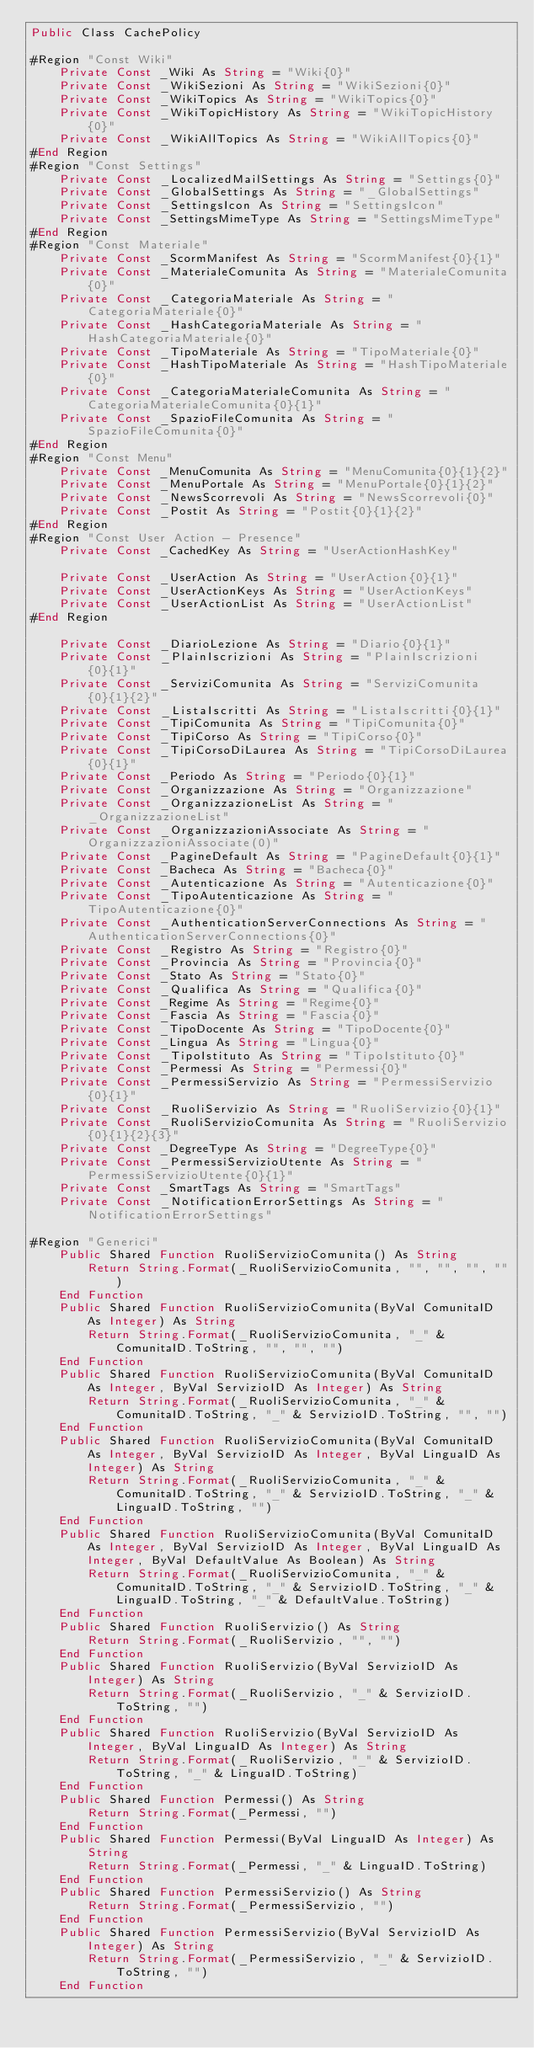<code> <loc_0><loc_0><loc_500><loc_500><_VisualBasic_>Public Class CachePolicy

#Region "Const Wiki"
	Private Const _Wiki As String = "Wiki{0}"
	Private Const _WikiSezioni As String = "WikiSezioni{0}"
	Private Const _WikiTopics As String = "WikiTopics{0}"
	Private Const _WikiTopicHistory As String = "WikiTopicHistory{0}"
	Private Const _WikiAllTopics As String = "WikiAllTopics{0}"
#End Region
#Region "Const Settings"
	Private Const _LocalizedMailSettings As String = "Settings{0}"
	Private Const _GlobalSettings As String = "_GlobalSettings"
	Private Const _SettingsIcon As String = "SettingsIcon"
	Private Const _SettingsMimeType As String = "SettingsMimeType"
#End Region
#Region "Const Materiale"
	Private Const _ScormManifest As String = "ScormManifest{0}{1}"
	Private Const _MaterialeComunita As String = "MaterialeComunita{0}"
	Private Const _CategoriaMateriale As String = "CategoriaMateriale{0}"
	Private Const _HashCategoriaMateriale As String = "HashCategoriaMateriale{0}"
	Private Const _TipoMateriale As String = "TipoMateriale{0}"
	Private Const _HashTipoMateriale As String = "HashTipoMateriale{0}"
	Private Const _CategoriaMaterialeComunita As String = "CategoriaMaterialeComunita{0}{1}"
	Private Const _SpazioFileComunita As String = "SpazioFileComunita{0}"
#End Region
#Region "Const Menu"
	Private Const _MenuComunita As String = "MenuComunita{0}{1}{2}"
	Private Const _MenuPortale As String = "MenuPortale{0}{1}{2}"
	Private Const _NewsScorrevoli As String = "NewsScorrevoli{0}"
	Private Const _Postit As String = "Postit{0}{1}{2}"
#End Region
#Region "Const User Action - Presence"
    Private Const _CachedKey As String = "UserActionHashKey"

    Private Const _UserAction As String = "UserAction{0}{1}"
    Private Const _UserActionKeys As String = "UserActionKeys"
    Private Const _UserActionList As String = "UserActionList"
#End Region

    Private Const _DiarioLezione As String = "Diario{0}{1}"
    Private Const _PlainIscrizioni As String = "PlainIscrizioni{0}{1}"
    Private Const _ServiziComunita As String = "ServiziComunita{0}{1}{2}"
    Private Const _ListaIscritti As String = "ListaIscritti{0}{1}"
    Private Const _TipiComunita As String = "TipiComunita{0}"
    Private Const _TipiCorso As String = "TipiCorso{0}"
    Private Const _TipiCorsoDiLaurea As String = "TipiCorsoDiLaurea{0}{1}"
    Private Const _Periodo As String = "Periodo{0}{1}"
    Private Const _Organizzazione As String = "Organizzazione"
    Private Const _OrganizzazioneList As String = "_OrganizzazioneList"
    Private Const _OrganizzazioniAssociate As String = "OrganizzazioniAssociate(0)"
    Private Const _PagineDefault As String = "PagineDefault{0}{1}"
    Private Const _Bacheca As String = "Bacheca{0}"
    Private Const _Autenticazione As String = "Autenticazione{0}"
    Private Const _TipoAutenticazione As String = "TipoAutenticazione{0}"
    Private Const _AuthenticationServerConnections As String = "AuthenticationServerConnections{0}"
    Private Const _Registro As String = "Registro{0}"
    Private Const _Provincia As String = "Provincia{0}"
    Private Const _Stato As String = "Stato{0}"
    Private Const _Qualifica As String = "Qualifica{0}"
    Private Const _Regime As String = "Regime{0}"
    Private Const _Fascia As String = "Fascia{0}"
    Private Const _TipoDocente As String = "TipoDocente{0}"
    Private Const _Lingua As String = "Lingua{0}"
    Private Const _TipoIstituto As String = "TipoIstituto{0}"
    Private Const _Permessi As String = "Permessi{0}"
    Private Const _PermessiServizio As String = "PermessiServizio{0}{1}"
    Private Const _RuoliServizio As String = "RuoliServizio{0}{1}"
    Private Const _RuoliServizioComunita As String = "RuoliServizio{0}{1}{2}{3}"
    Private Const _DegreeType As String = "DegreeType{0}"
	Private Const _PermessiServizioUtente As String = "PermessiServizioUtente{0}{1}"
    Private Const _SmartTags As String = "SmartTags"
    Private Const _NotificationErrorSettings As String = "NotificationErrorSettings"

#Region "Generici"
    Public Shared Function RuoliServizioComunita() As String
        Return String.Format(_RuoliServizioComunita, "", "", "", "")
    End Function
    Public Shared Function RuoliServizioComunita(ByVal ComunitaID As Integer) As String
        Return String.Format(_RuoliServizioComunita, "_" & ComunitaID.ToString, "", "", "")
    End Function
    Public Shared Function RuoliServizioComunita(ByVal ComunitaID As Integer, ByVal ServizioID As Integer) As String
        Return String.Format(_RuoliServizioComunita, "_" & ComunitaID.ToString, "_" & ServizioID.ToString, "", "")
    End Function
    Public Shared Function RuoliServizioComunita(ByVal ComunitaID As Integer, ByVal ServizioID As Integer, ByVal LinguaID As Integer) As String
        Return String.Format(_RuoliServizioComunita, "_" & ComunitaID.ToString, "_" & ServizioID.ToString, "_" & LinguaID.ToString, "")
    End Function
    Public Shared Function RuoliServizioComunita(ByVal ComunitaID As Integer, ByVal ServizioID As Integer, ByVal LinguaID As Integer, ByVal DefaultValue As Boolean) As String
        Return String.Format(_RuoliServizioComunita, "_" & ComunitaID.ToString, "_" & ServizioID.ToString, "_" & LinguaID.ToString, "_" & DefaultValue.ToString)
    End Function
    Public Shared Function RuoliServizio() As String
        Return String.Format(_RuoliServizio, "", "")
    End Function
    Public Shared Function RuoliServizio(ByVal ServizioID As Integer) As String
        Return String.Format(_RuoliServizio, "_" & ServizioID.ToString, "")
    End Function
    Public Shared Function RuoliServizio(ByVal ServizioID As Integer, ByVal LinguaID As Integer) As String
        Return String.Format(_RuoliServizio, "_" & ServizioID.ToString, "_" & LinguaID.ToString)
    End Function
    Public Shared Function Permessi() As String
        Return String.Format(_Permessi, "")
    End Function
    Public Shared Function Permessi(ByVal LinguaID As Integer) As String
        Return String.Format(_Permessi, "_" & LinguaID.ToString)
    End Function
    Public Shared Function PermessiServizio() As String
        Return String.Format(_PermessiServizio, "")
    End Function
    Public Shared Function PermessiServizio(ByVal ServizioID As Integer) As String
        Return String.Format(_PermessiServizio, "_" & ServizioID.ToString, "")
    End Function</code> 